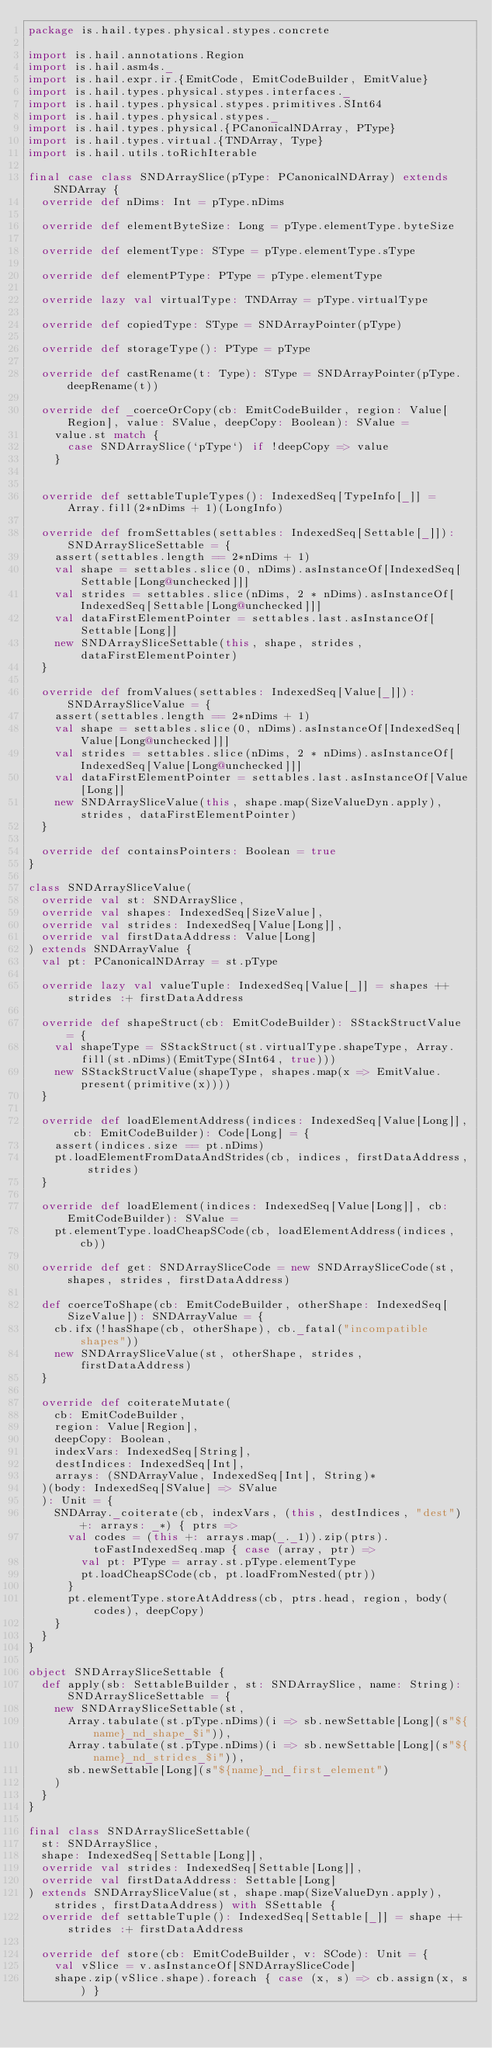<code> <loc_0><loc_0><loc_500><loc_500><_Scala_>package is.hail.types.physical.stypes.concrete

import is.hail.annotations.Region
import is.hail.asm4s._
import is.hail.expr.ir.{EmitCode, EmitCodeBuilder, EmitValue}
import is.hail.types.physical.stypes.interfaces._
import is.hail.types.physical.stypes.primitives.SInt64
import is.hail.types.physical.stypes._
import is.hail.types.physical.{PCanonicalNDArray, PType}
import is.hail.types.virtual.{TNDArray, Type}
import is.hail.utils.toRichIterable

final case class SNDArraySlice(pType: PCanonicalNDArray) extends SNDArray {
  override def nDims: Int = pType.nDims

  override def elementByteSize: Long = pType.elementType.byteSize

  override def elementType: SType = pType.elementType.sType

  override def elementPType: PType = pType.elementType

  override lazy val virtualType: TNDArray = pType.virtualType

  override def copiedType: SType = SNDArrayPointer(pType)

  override def storageType(): PType = pType

  override def castRename(t: Type): SType = SNDArrayPointer(pType.deepRename(t))

  override def _coerceOrCopy(cb: EmitCodeBuilder, region: Value[Region], value: SValue, deepCopy: Boolean): SValue =
    value.st match {
      case SNDArraySlice(`pType`) if !deepCopy => value
    }


  override def settableTupleTypes(): IndexedSeq[TypeInfo[_]] = Array.fill(2*nDims + 1)(LongInfo)

  override def fromSettables(settables: IndexedSeq[Settable[_]]): SNDArraySliceSettable = {
    assert(settables.length == 2*nDims + 1)
    val shape = settables.slice(0, nDims).asInstanceOf[IndexedSeq[Settable[Long@unchecked]]]
    val strides = settables.slice(nDims, 2 * nDims).asInstanceOf[IndexedSeq[Settable[Long@unchecked]]]
    val dataFirstElementPointer = settables.last.asInstanceOf[Settable[Long]]
    new SNDArraySliceSettable(this, shape, strides, dataFirstElementPointer)
  }

  override def fromValues(settables: IndexedSeq[Value[_]]): SNDArraySliceValue = {
    assert(settables.length == 2*nDims + 1)
    val shape = settables.slice(0, nDims).asInstanceOf[IndexedSeq[Value[Long@unchecked]]]
    val strides = settables.slice(nDims, 2 * nDims).asInstanceOf[IndexedSeq[Value[Long@unchecked]]]
    val dataFirstElementPointer = settables.last.asInstanceOf[Value[Long]]
    new SNDArraySliceValue(this, shape.map(SizeValueDyn.apply), strides, dataFirstElementPointer)
  }

  override def containsPointers: Boolean = true
}

class SNDArraySliceValue(
  override val st: SNDArraySlice,
  override val shapes: IndexedSeq[SizeValue],
  override val strides: IndexedSeq[Value[Long]],
  override val firstDataAddress: Value[Long]
) extends SNDArrayValue {
  val pt: PCanonicalNDArray = st.pType

  override lazy val valueTuple: IndexedSeq[Value[_]] = shapes ++ strides :+ firstDataAddress

  override def shapeStruct(cb: EmitCodeBuilder): SStackStructValue = {
    val shapeType = SStackStruct(st.virtualType.shapeType, Array.fill(st.nDims)(EmitType(SInt64, true)))
    new SStackStructValue(shapeType, shapes.map(x => EmitValue.present(primitive(x))))
  }

  override def loadElementAddress(indices: IndexedSeq[Value[Long]], cb: EmitCodeBuilder): Code[Long] = {
    assert(indices.size == pt.nDims)
    pt.loadElementFromDataAndStrides(cb, indices, firstDataAddress, strides)
  }

  override def loadElement(indices: IndexedSeq[Value[Long]], cb: EmitCodeBuilder): SValue =
    pt.elementType.loadCheapSCode(cb, loadElementAddress(indices, cb))

  override def get: SNDArraySliceCode = new SNDArraySliceCode(st, shapes, strides, firstDataAddress)

  def coerceToShape(cb: EmitCodeBuilder, otherShape: IndexedSeq[SizeValue]): SNDArrayValue = {
    cb.ifx(!hasShape(cb, otherShape), cb._fatal("incompatible shapes"))
    new SNDArraySliceValue(st, otherShape, strides, firstDataAddress)
  }

  override def coiterateMutate(
    cb: EmitCodeBuilder,
    region: Value[Region],
    deepCopy: Boolean,
    indexVars: IndexedSeq[String],
    destIndices: IndexedSeq[Int],
    arrays: (SNDArrayValue, IndexedSeq[Int], String)*
  )(body: IndexedSeq[SValue] => SValue
  ): Unit = {
    SNDArray._coiterate(cb, indexVars, (this, destIndices, "dest") +: arrays: _*) { ptrs =>
      val codes = (this +: arrays.map(_._1)).zip(ptrs).toFastIndexedSeq.map { case (array, ptr) =>
        val pt: PType = array.st.pType.elementType
        pt.loadCheapSCode(cb, pt.loadFromNested(ptr))
      }
      pt.elementType.storeAtAddress(cb, ptrs.head, region, body(codes), deepCopy)
    }
  }
}

object SNDArraySliceSettable {
  def apply(sb: SettableBuilder, st: SNDArraySlice, name: String): SNDArraySliceSettable = {
    new SNDArraySliceSettable(st,
      Array.tabulate(st.pType.nDims)(i => sb.newSettable[Long](s"${name}_nd_shape_$i")),
      Array.tabulate(st.pType.nDims)(i => sb.newSettable[Long](s"${name}_nd_strides_$i")),
      sb.newSettable[Long](s"${name}_nd_first_element")
    )
  }
}

final class SNDArraySliceSettable(
  st: SNDArraySlice,
  shape: IndexedSeq[Settable[Long]],
  override val strides: IndexedSeq[Settable[Long]],
  override val firstDataAddress: Settable[Long]
) extends SNDArraySliceValue(st, shape.map(SizeValueDyn.apply), strides, firstDataAddress) with SSettable {
  override def settableTuple(): IndexedSeq[Settable[_]] = shape ++ strides :+ firstDataAddress

  override def store(cb: EmitCodeBuilder, v: SCode): Unit = {
    val vSlice = v.asInstanceOf[SNDArraySliceCode]
    shape.zip(vSlice.shape).foreach { case (x, s) => cb.assign(x, s) }</code> 